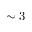Convert formula to latex. <formula><loc_0><loc_0><loc_500><loc_500>\sim 3</formula> 